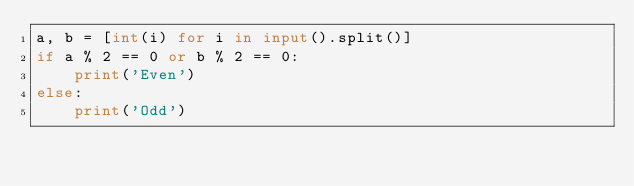<code> <loc_0><loc_0><loc_500><loc_500><_Python_>a, b = [int(i) for i in input().split()]
if a % 2 == 0 or b % 2 == 0:
    print('Even')
else:
    print('Odd')
</code> 